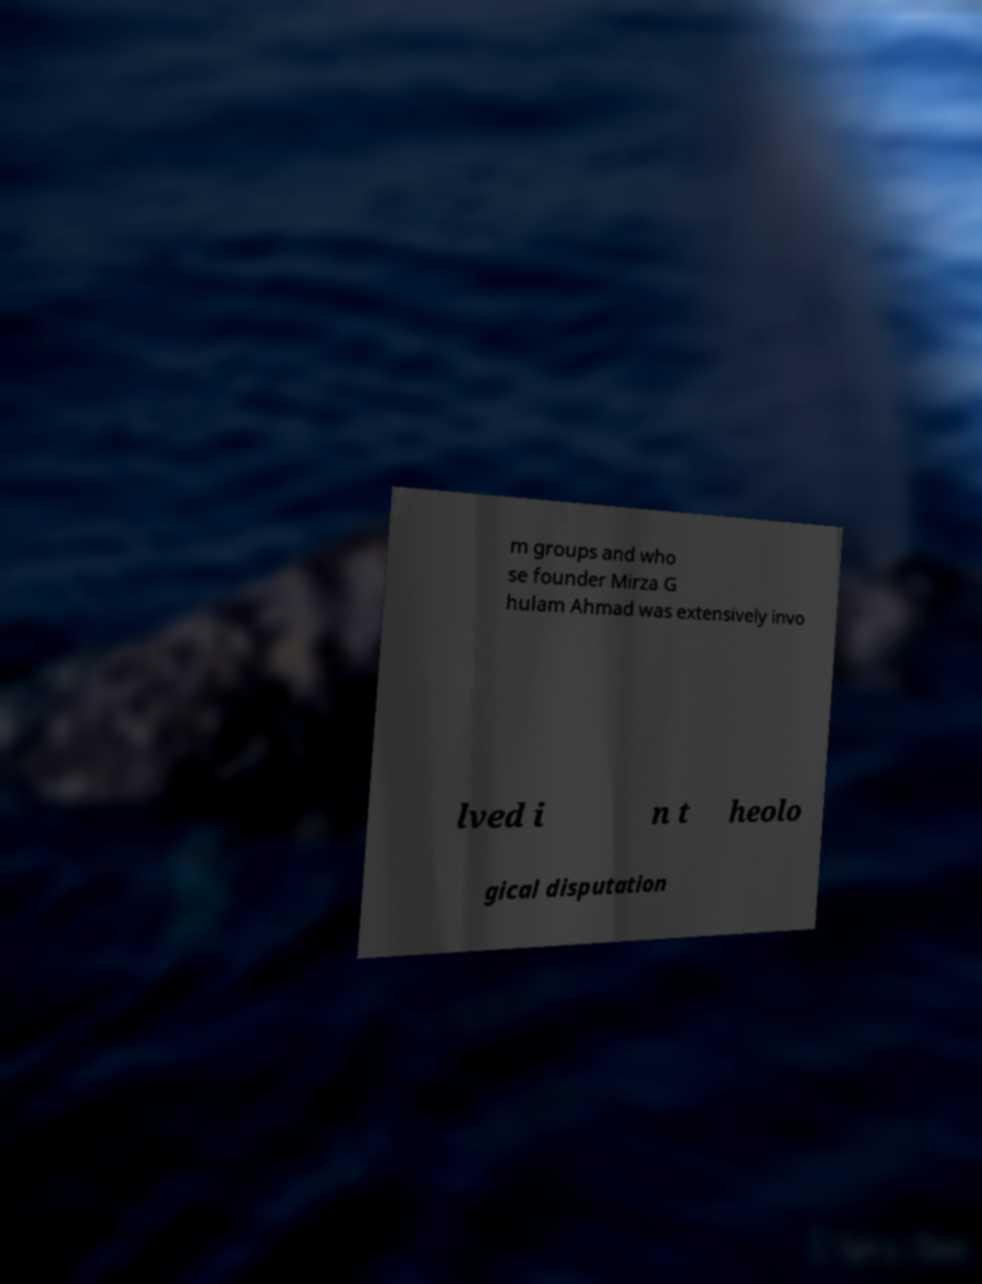Can you accurately transcribe the text from the provided image for me? m groups and who se founder Mirza G hulam Ahmad was extensively invo lved i n t heolo gical disputation 